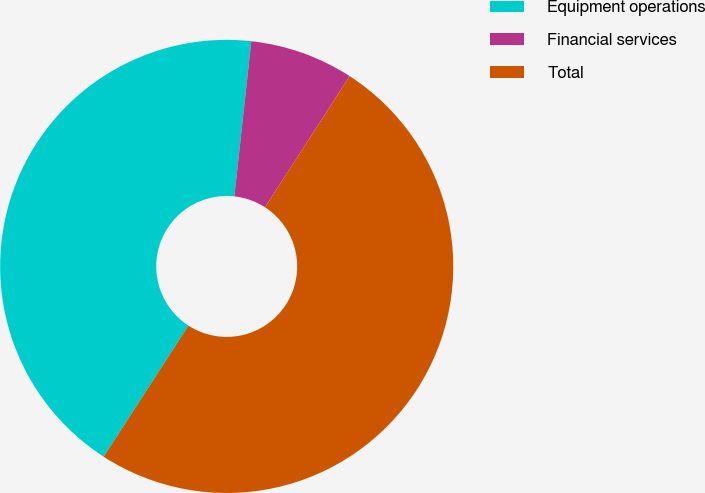Convert chart. <chart><loc_0><loc_0><loc_500><loc_500><pie_chart><fcel>Equipment operations<fcel>Financial services<fcel>Total<nl><fcel>42.6%<fcel>7.4%<fcel>50.0%<nl></chart> 